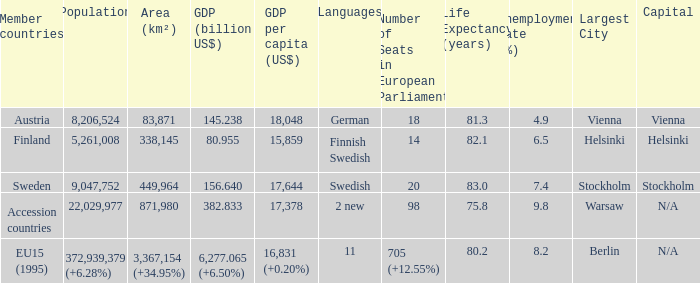Name the area for german 83871.0. 